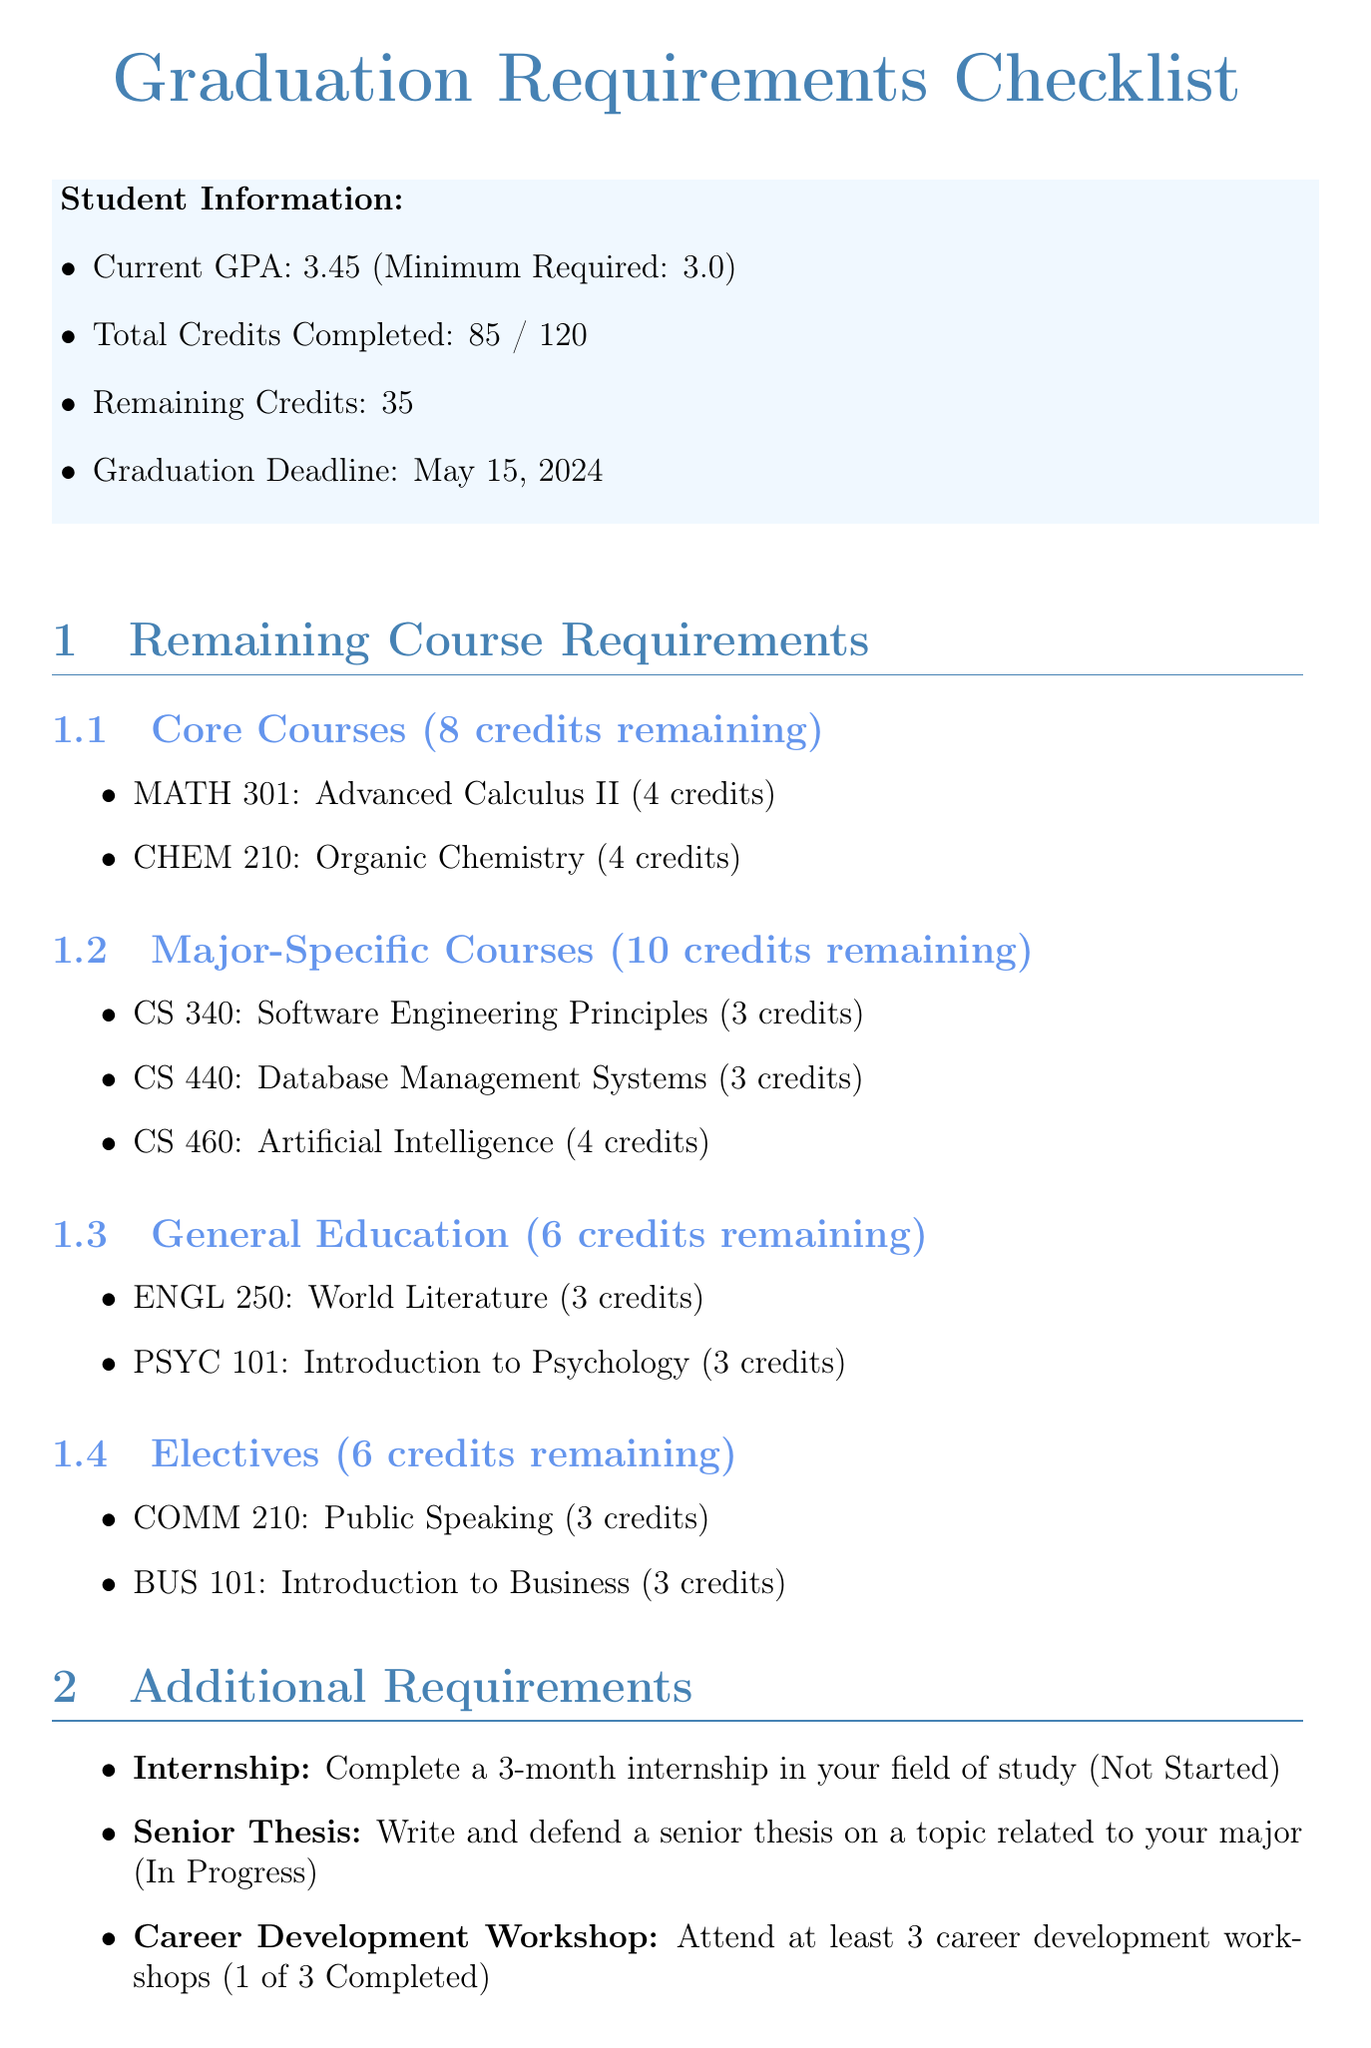What are the remaining credits needed for graduation? The document states that there are 35 remaining credits needed for graduation.
Answer: 35 Who is the academic advisor? The document specifies that the academic advisor is Dr. Sarah Johnson.
Answer: Dr. Sarah Johnson What is the status of the Internship requirement? The document indicates that the Internship requirement has not been started yet.
Answer: Not Started How many major-specific courses credits are remaining? The document shows that there are 10 credits remaining for major-specific courses.
Answer: 10 When is the graduation deadline? The document lists May 15, 2024, as the graduation deadline.
Answer: May 15, 2024 What is the current GPA? The document reports that the current GPA is 3.45.
Answer: 3.45 How many career development workshops need to be attended? The document states that at least 3 career development workshops need to be attended.
Answer: 3 What credit is needed to complete Advanced Calculus II? The document specifies that Advanced Calculus II requires 4 credits to complete.
Answer: 4 credits How many remaining courses are there in General Education? The document lists 2 remaining courses in General Education.
Answer: 2 